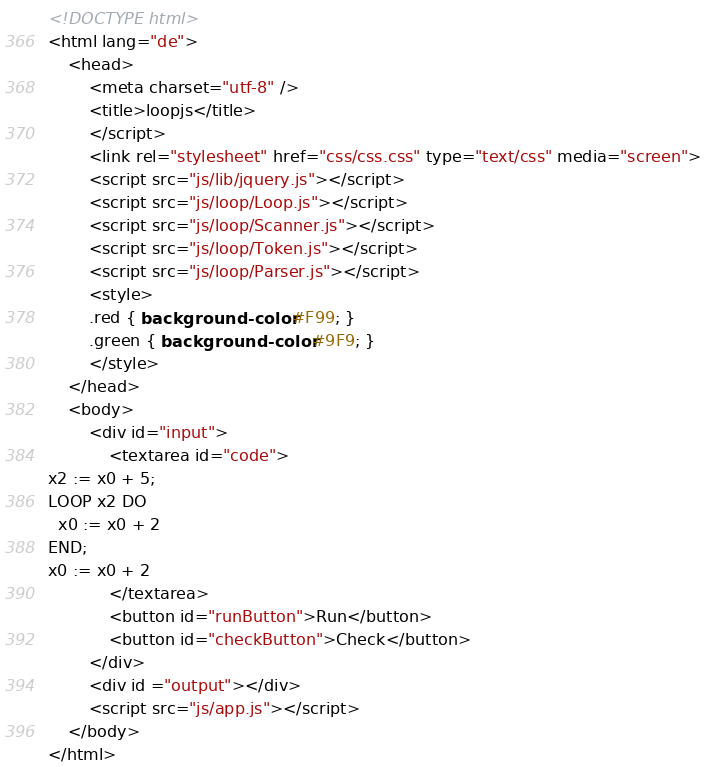<code> <loc_0><loc_0><loc_500><loc_500><_HTML_><!DOCTYPE html>
<html lang="de">
	<head>
		<meta charset="utf-8" />
		<title>loopjs</title>
		</script>
		<link rel="stylesheet" href="css/css.css" type="text/css" media="screen">
		<script src="js/lib/jquery.js"></script>
		<script src="js/loop/Loop.js"></script>
		<script src="js/loop/Scanner.js"></script>
		<script src="js/loop/Token.js"></script>
		<script src="js/loop/Parser.js"></script>
		<style>
		.red { background-color: #F99; }
		.green { background-color: #9F9; }
		</style>
	</head>
	<body>
		<div id="input">
			<textarea id="code">
x2 := x0 + 5;
LOOP x2 DO
  x0 := x0 + 2
END;
x0 := x0 + 2
			</textarea>
			<button id="runButton">Run</button>
			<button id="checkButton">Check</button>
		</div>
		<div id ="output"></div>
		<script src="js/app.js"></script>
	</body>
</html></code> 